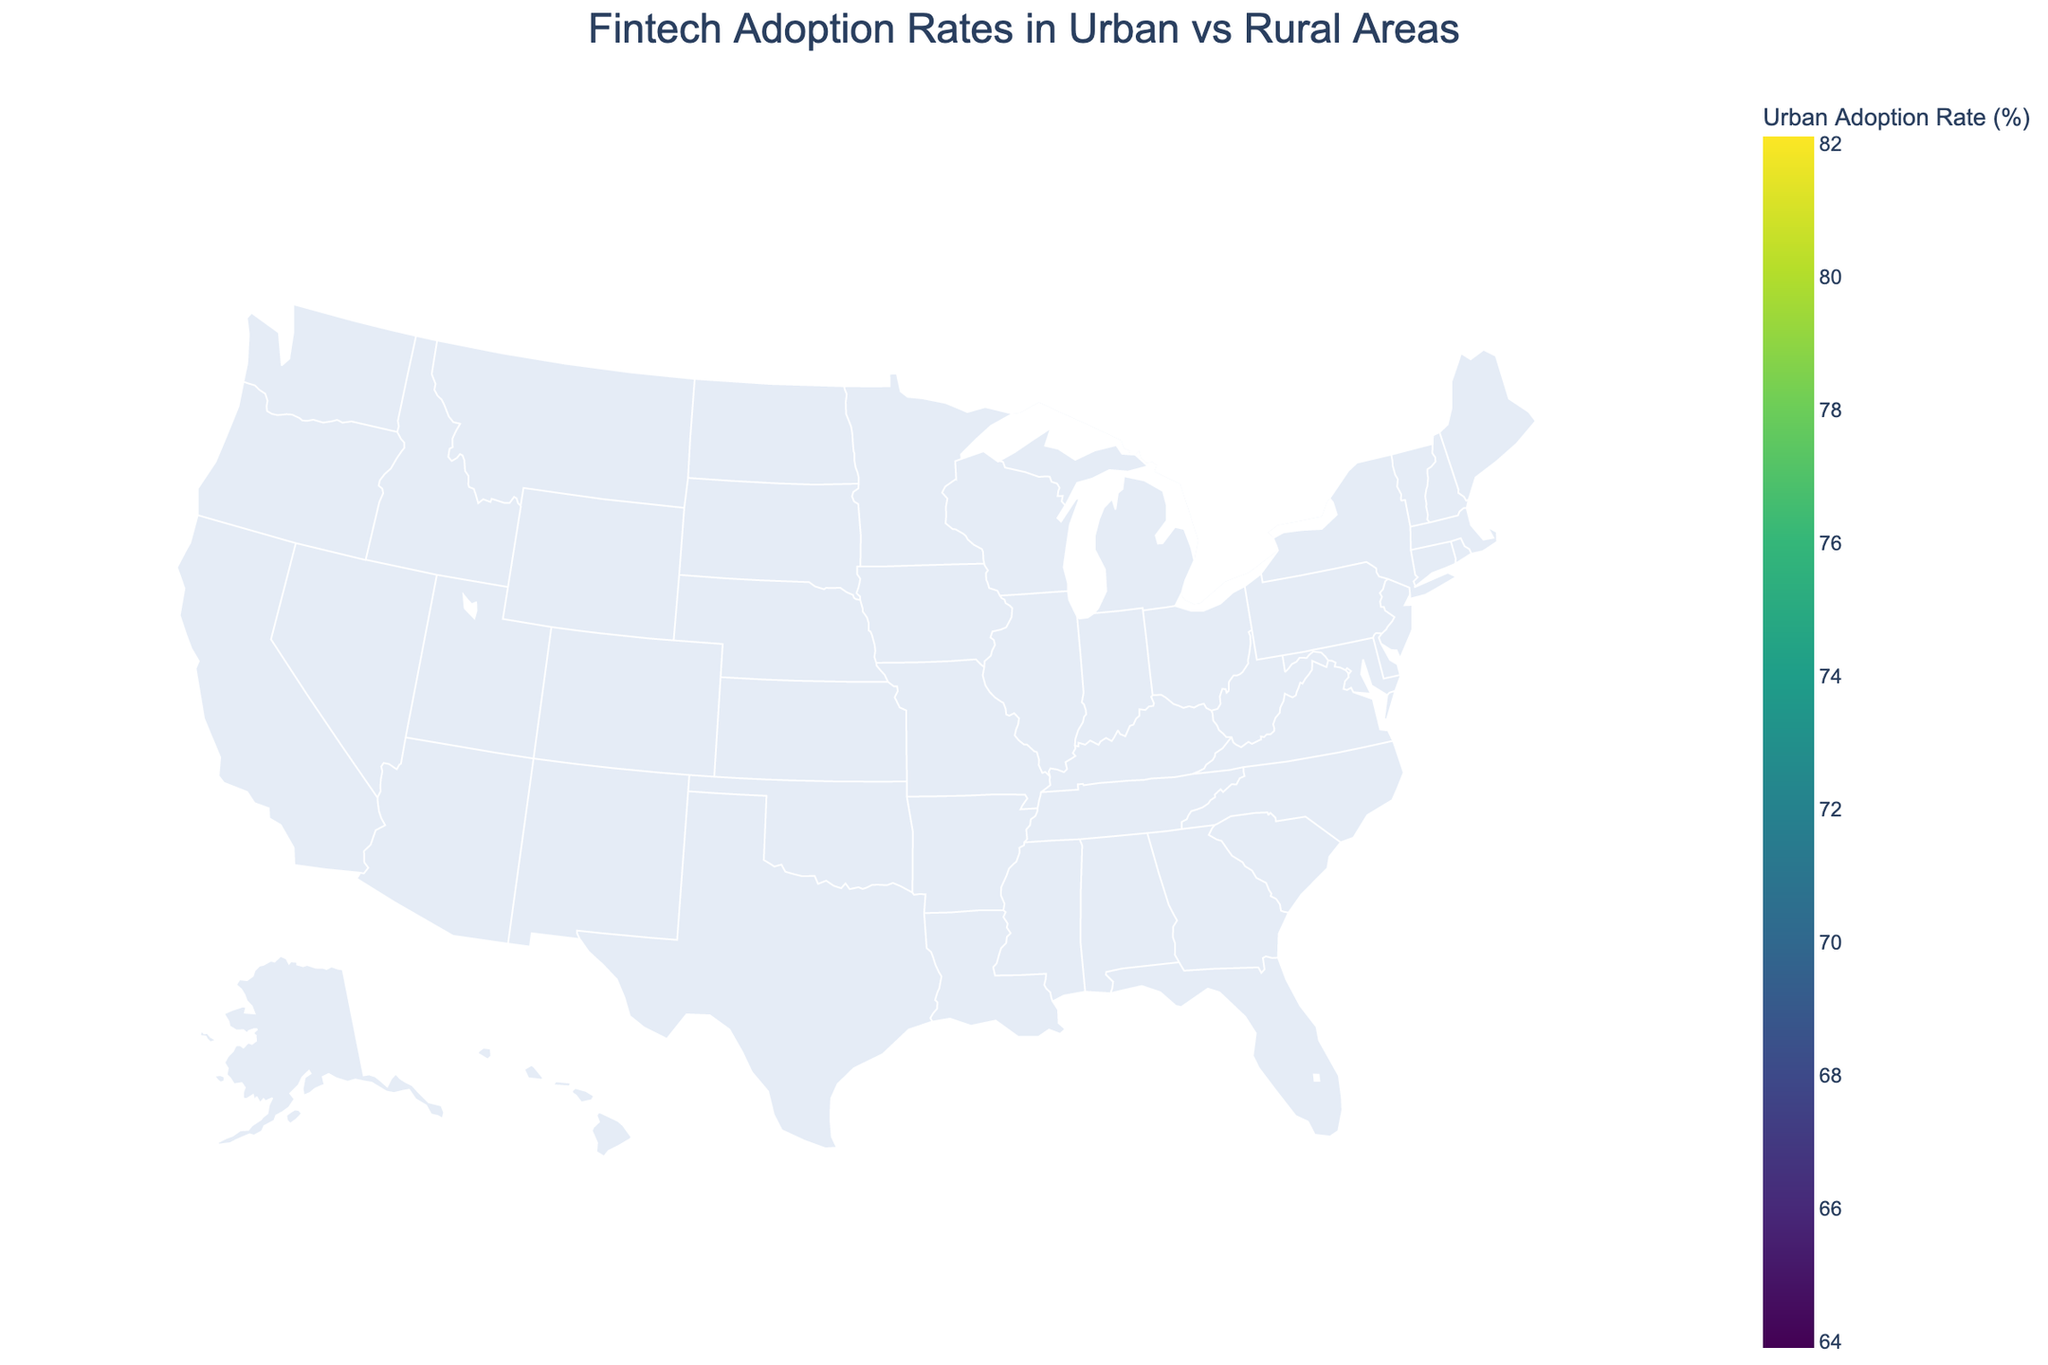What is the urban adoption rate in New York? The urban adoption rate in New York can be directly read from the figure by finding the value for New York on the map.
Answer: 78.5% Which state has the highest urban adoption rate? To find the state with the highest urban adoption rate, compare the values for each state and identify the maximum.
Answer: California How does the urban adoption rate in Ohio compare to its rural adoption rate? The urban adoption rate in Ohio is 67.9%, and the rural adoption rate is 30.1%. Comparing these two values: 67.9% is greater than 30.1%.
Answer: Urban rate is greater What is the difference between the urban and rural adoption rates in Texas? Subtract the rural adoption rate (36.9%) from the urban adoption rate (75.6%) for Texas. The difference is 75.6% - 36.9%.
Answer: 38.7% Which region has the smallest gap between urban and rural adoption rates? Calculate the difference between urban and rural adoption rates for each region, then identify the smallest difference.
Answer: Florida (37.4%) Overall, which type of area (urban or rural) typically has higher fintech adoption rates? By viewing the plot, it's apparent that urban areas have significantly higher fintech adoption rates compared to rural areas across all regions.
Answer: Urban areas What is the average rural adoption rate across all regions? Sum the rural adoption rates and divide by the number of regions: (42.3 + 39.7 + 36.9 + 35.8 + 33.5 + 31.2 + 30.1 + 32.7 + 29.8 + 28.4 + 34.6 + 38.2 + 37.9 + 34.1 + 30.9 + 27.6 + 26.9 + 35.3 + 26.2 + 36.5) / 20.
Answer: 33.8% Which state is represented by the largest marker on the map for rural adoption rates? The largest marker indicates the highest rural adoption rate. Identify the state with the highest value.
Answer: New York What is the title of the plot? The title is usually displayed at the top of the figure.
Answer: Fintech Adoption Rates in Urban vs Rural Areas 